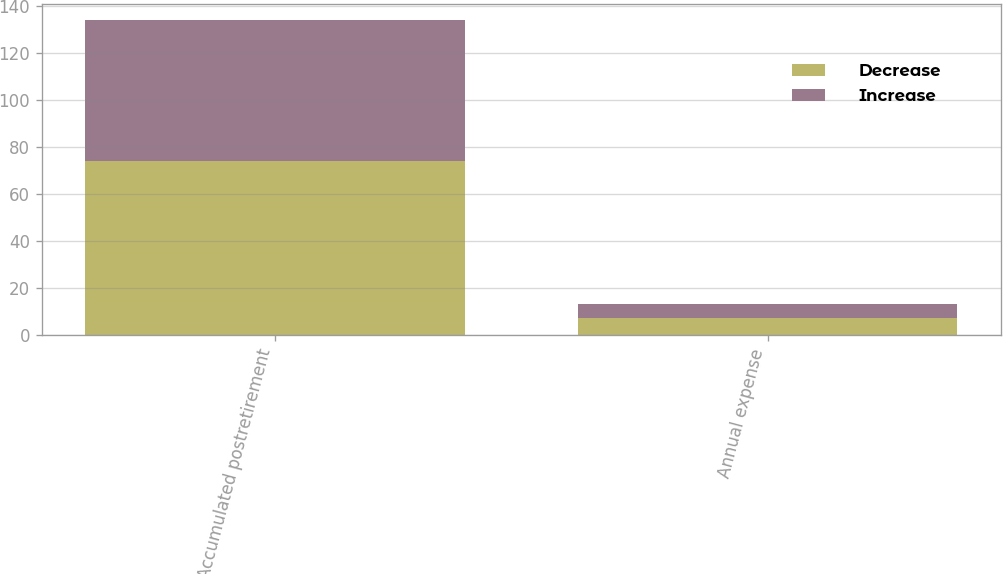<chart> <loc_0><loc_0><loc_500><loc_500><stacked_bar_chart><ecel><fcel>Accumulated postretirement<fcel>Annual expense<nl><fcel>Decrease<fcel>74<fcel>7<nl><fcel>Increase<fcel>60<fcel>6<nl></chart> 